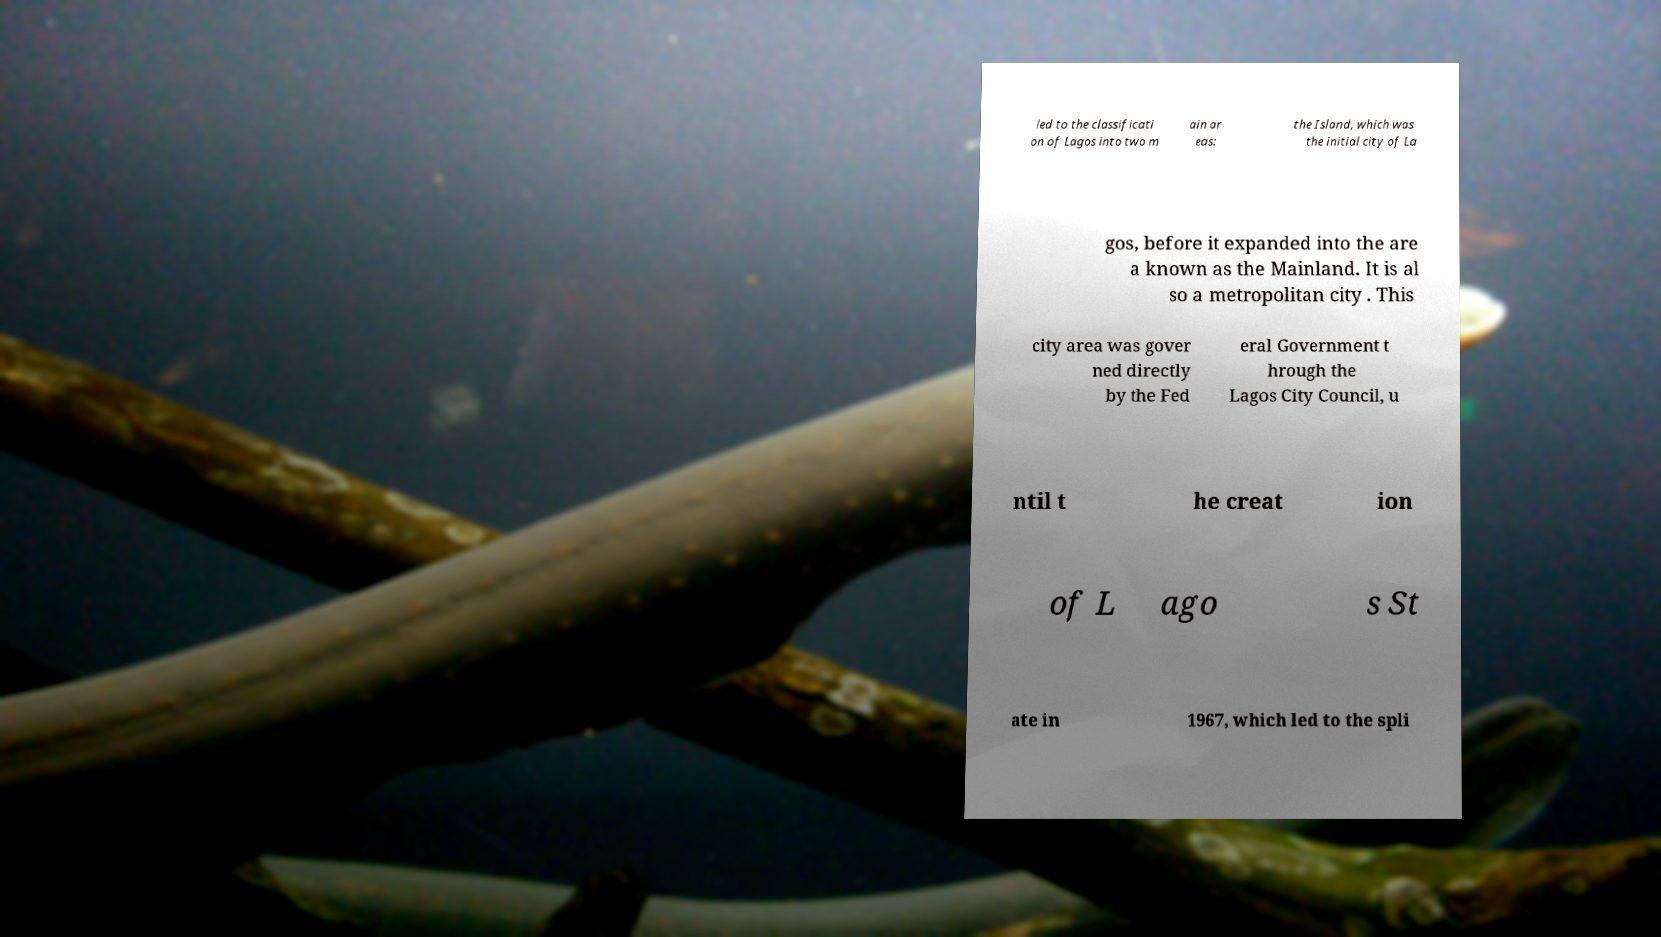Can you read and provide the text displayed in the image?This photo seems to have some interesting text. Can you extract and type it out for me? led to the classificati on of Lagos into two m ain ar eas: the Island, which was the initial city of La gos, before it expanded into the are a known as the Mainland. It is al so a metropolitan city . This city area was gover ned directly by the Fed eral Government t hrough the Lagos City Council, u ntil t he creat ion of L ago s St ate in 1967, which led to the spli 